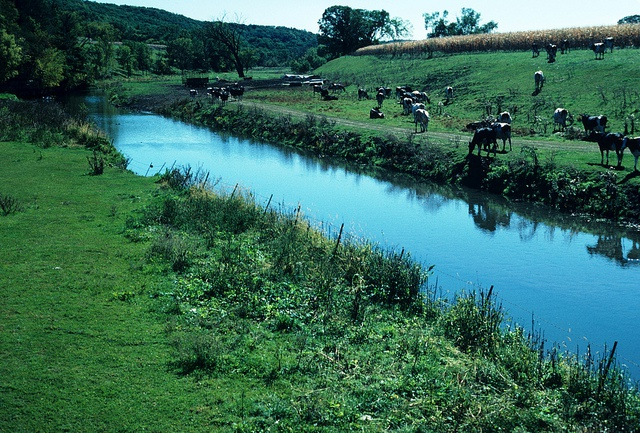Describe the objects in this image and their specific colors. I can see cow in black, teal, and green tones, cow in black, teal, and darkgreen tones, cow in black, teal, navy, and green tones, cow in black, navy, and teal tones, and cow in black, teal, darkblue, and white tones in this image. 